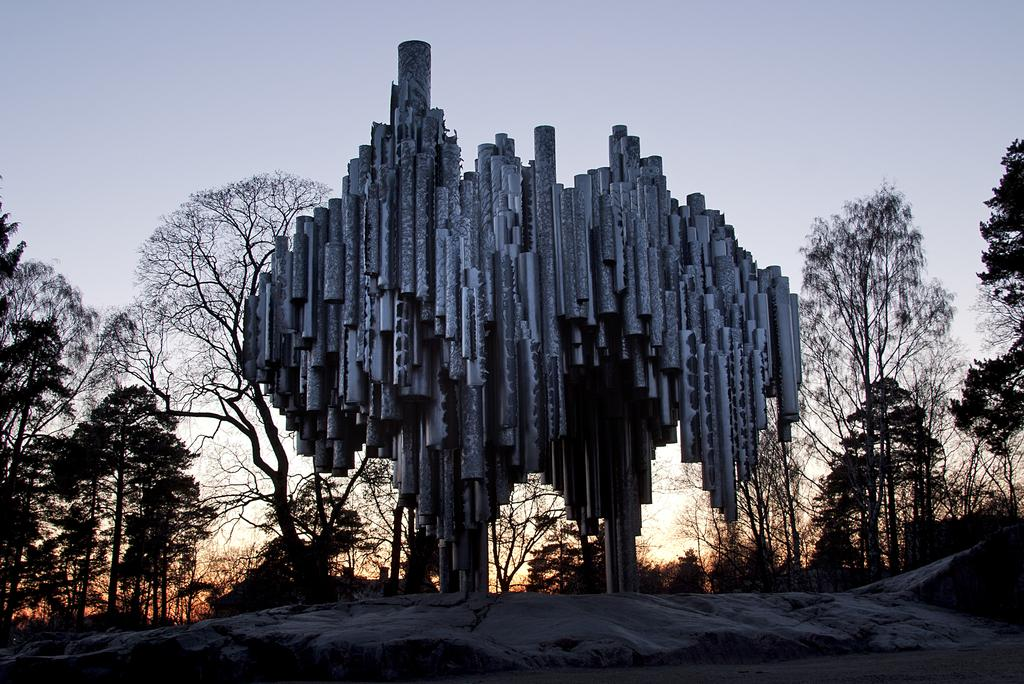What is located in the middle of the ground in the image? There is a pipe frame in the middle of the ground. What can be seen in the background of the image? There are many dry trees visible in the background. How would you describe the sky in the background of the image? The sky in the background appears to be a sunset sky. What type of linen is draped over the pipe frame in the image? There is no linen present in the image; it features a pipe frame and dry trees in the background. 